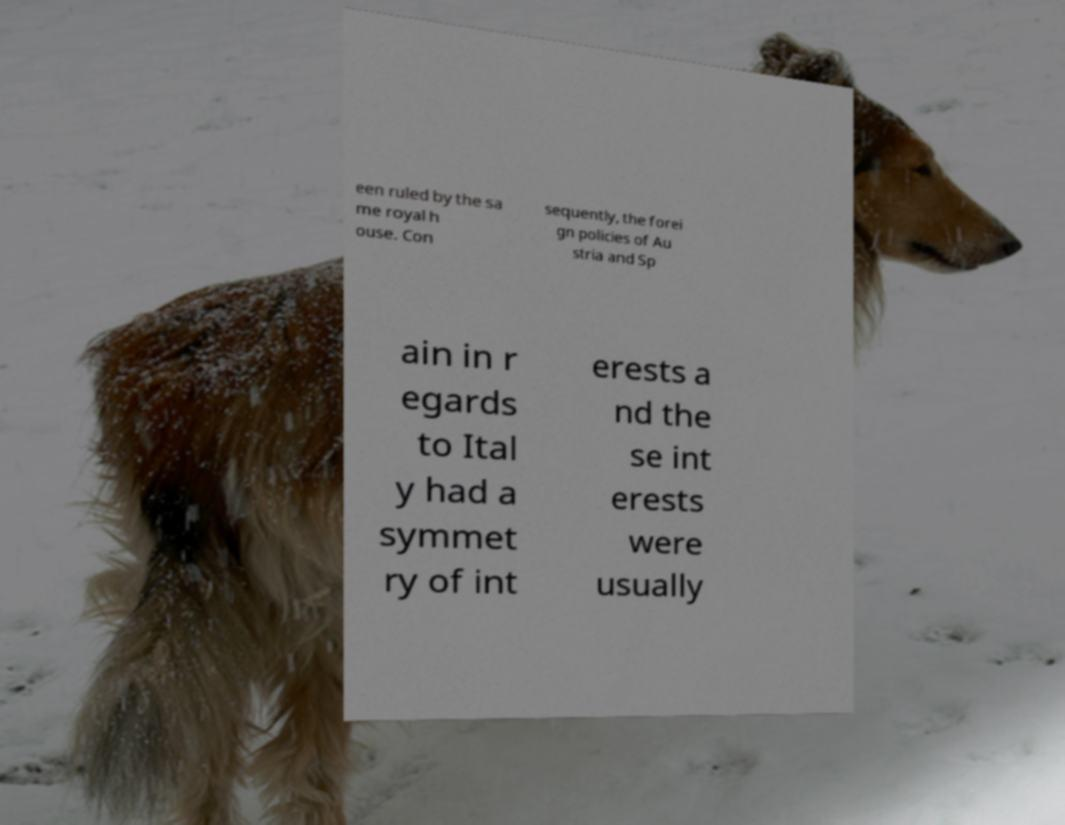Please identify and transcribe the text found in this image. een ruled by the sa me royal h ouse. Con sequently, the forei gn policies of Au stria and Sp ain in r egards to Ital y had a symmet ry of int erests a nd the se int erests were usually 